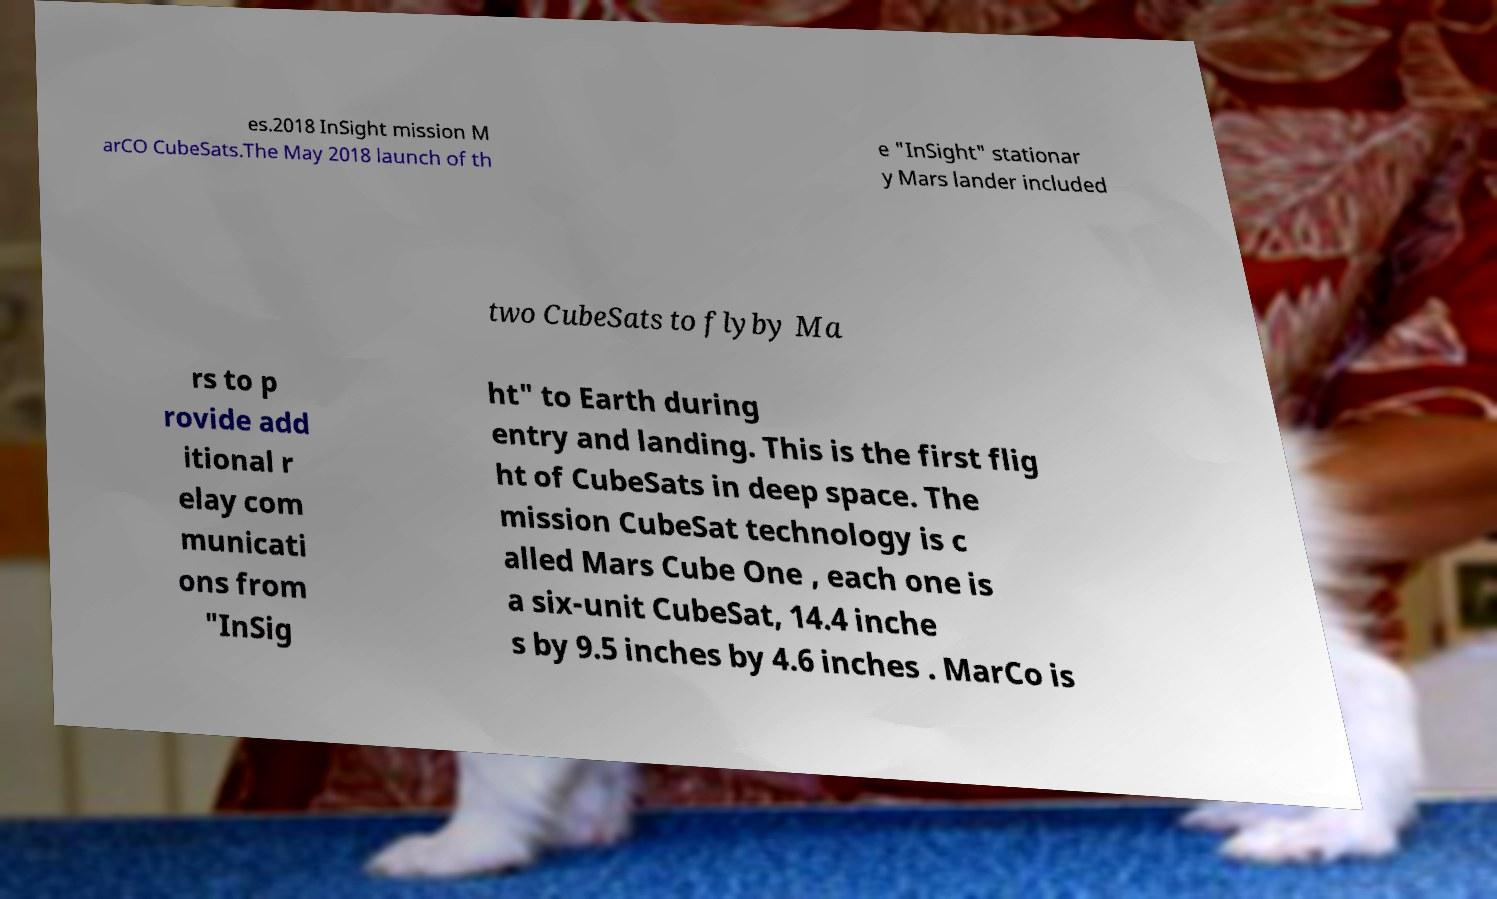There's text embedded in this image that I need extracted. Can you transcribe it verbatim? es.2018 InSight mission M arCO CubeSats.The May 2018 launch of th e "InSight" stationar y Mars lander included two CubeSats to flyby Ma rs to p rovide add itional r elay com municati ons from "InSig ht" to Earth during entry and landing. This is the first flig ht of CubeSats in deep space. The mission CubeSat technology is c alled Mars Cube One , each one is a six-unit CubeSat, 14.4 inche s by 9.5 inches by 4.6 inches . MarCo is 